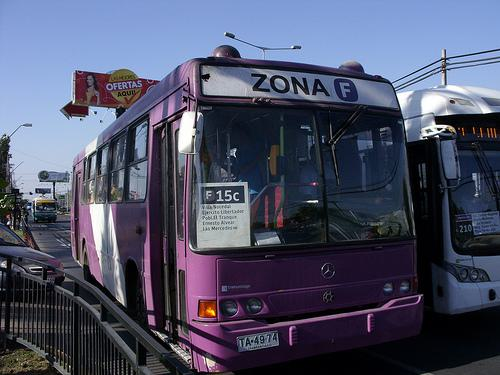What type of vehicle is prominently featured in this image? The predominant vehicle in the image is a purple bus, labeled 'Zona F', which seems to be a part of a public transportation system. 